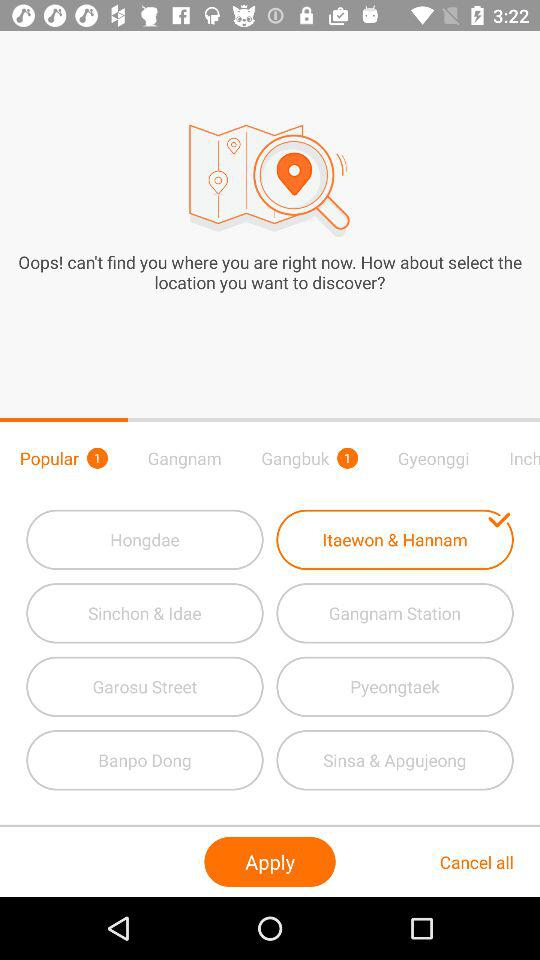How many popular locations are there? There is 1 popular location. 